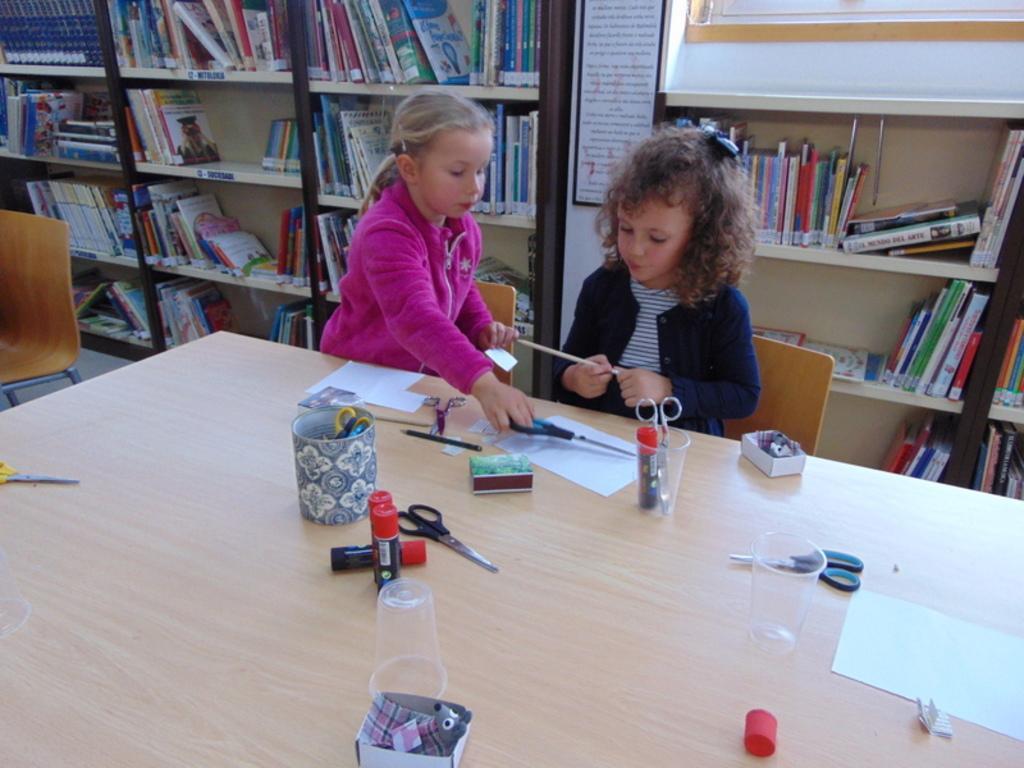Describe this image in one or two sentences. These two persons are sitting on the chairs. We can see box,scissors,toy,papers,pencil on the table. Behind these persons we can see shelves with books. This person holding pencil. This is floor. 